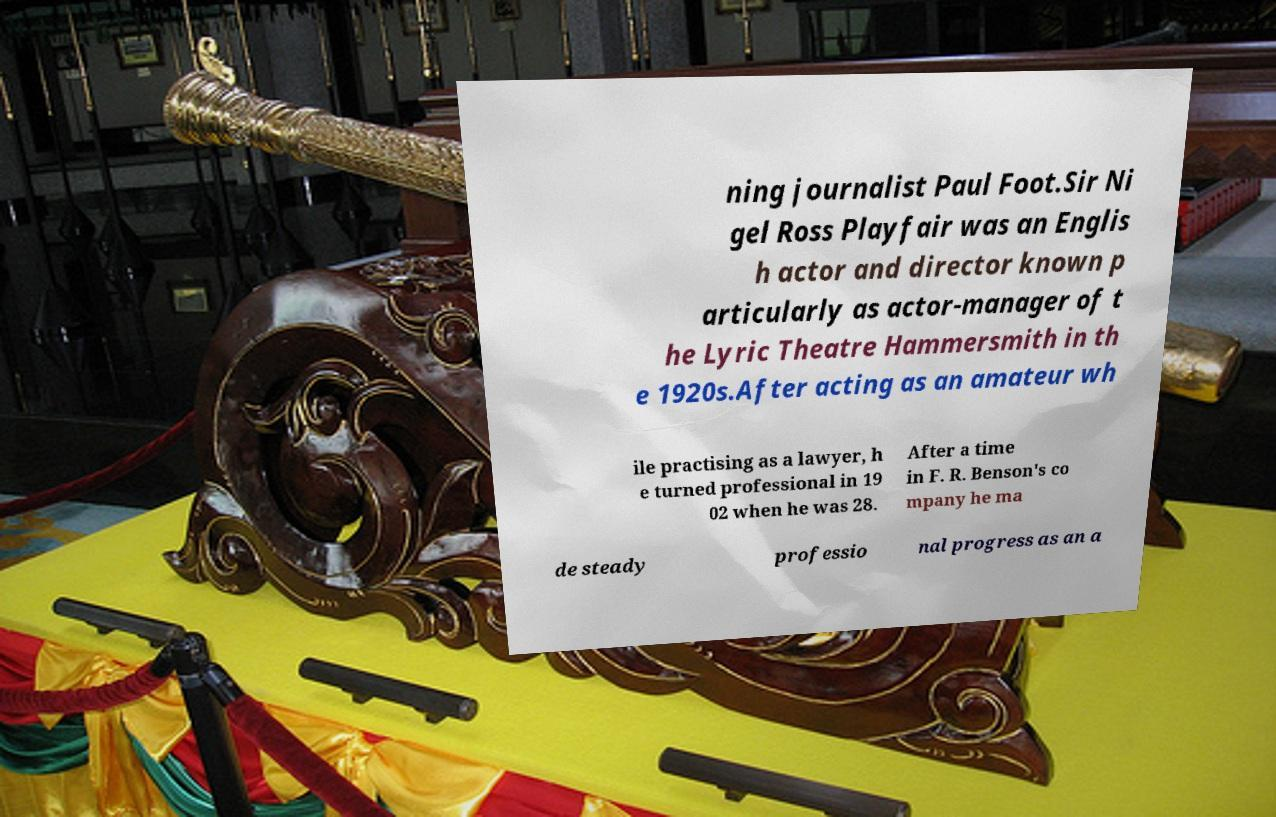For documentation purposes, I need the text within this image transcribed. Could you provide that? ning journalist Paul Foot.Sir Ni gel Ross Playfair was an Englis h actor and director known p articularly as actor-manager of t he Lyric Theatre Hammersmith in th e 1920s.After acting as an amateur wh ile practising as a lawyer, h e turned professional in 19 02 when he was 28. After a time in F. R. Benson's co mpany he ma de steady professio nal progress as an a 